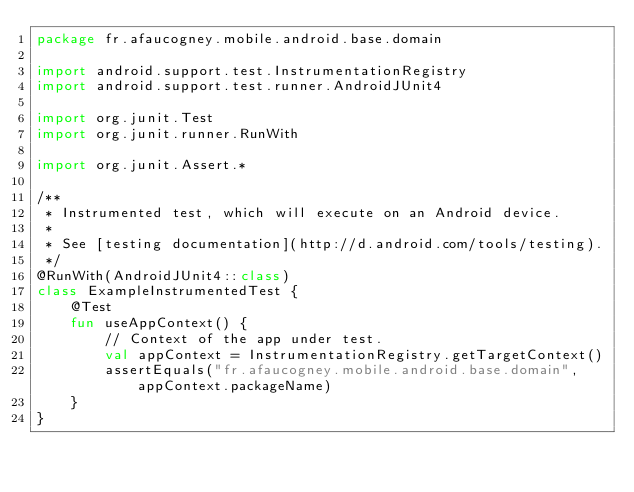Convert code to text. <code><loc_0><loc_0><loc_500><loc_500><_Kotlin_>package fr.afaucogney.mobile.android.base.domain

import android.support.test.InstrumentationRegistry
import android.support.test.runner.AndroidJUnit4

import org.junit.Test
import org.junit.runner.RunWith

import org.junit.Assert.*

/**
 * Instrumented test, which will execute on an Android device.
 *
 * See [testing documentation](http://d.android.com/tools/testing).
 */
@RunWith(AndroidJUnit4::class)
class ExampleInstrumentedTest {
    @Test
    fun useAppContext() {
        // Context of the app under test.
        val appContext = InstrumentationRegistry.getTargetContext()
        assertEquals("fr.afaucogney.mobile.android.base.domain", appContext.packageName)
    }
}
</code> 